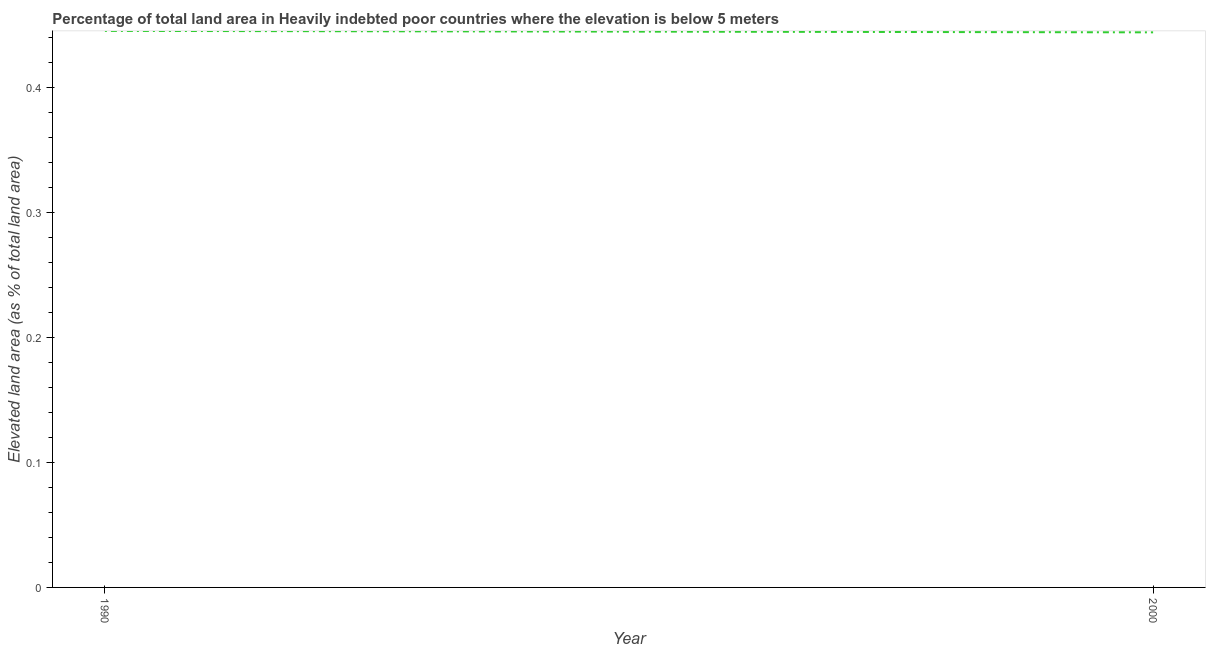What is the total elevated land area in 1990?
Provide a short and direct response. 0.44. Across all years, what is the maximum total elevated land area?
Your response must be concise. 0.44. Across all years, what is the minimum total elevated land area?
Give a very brief answer. 0.44. In which year was the total elevated land area maximum?
Your answer should be compact. 1990. In which year was the total elevated land area minimum?
Your answer should be very brief. 2000. What is the sum of the total elevated land area?
Provide a short and direct response. 0.89. What is the difference between the total elevated land area in 1990 and 2000?
Your response must be concise. 0. What is the average total elevated land area per year?
Your answer should be compact. 0.44. What is the median total elevated land area?
Your answer should be very brief. 0.44. What is the ratio of the total elevated land area in 1990 to that in 2000?
Provide a short and direct response. 1. Is the total elevated land area in 1990 less than that in 2000?
Ensure brevity in your answer.  No. Does the total elevated land area monotonically increase over the years?
Ensure brevity in your answer.  No. Are the values on the major ticks of Y-axis written in scientific E-notation?
Provide a succinct answer. No. What is the title of the graph?
Your answer should be very brief. Percentage of total land area in Heavily indebted poor countries where the elevation is below 5 meters. What is the label or title of the Y-axis?
Make the answer very short. Elevated land area (as % of total land area). What is the Elevated land area (as % of total land area) in 1990?
Keep it short and to the point. 0.44. What is the Elevated land area (as % of total land area) of 2000?
Make the answer very short. 0.44. What is the difference between the Elevated land area (as % of total land area) in 1990 and 2000?
Offer a very short reply. 0. 